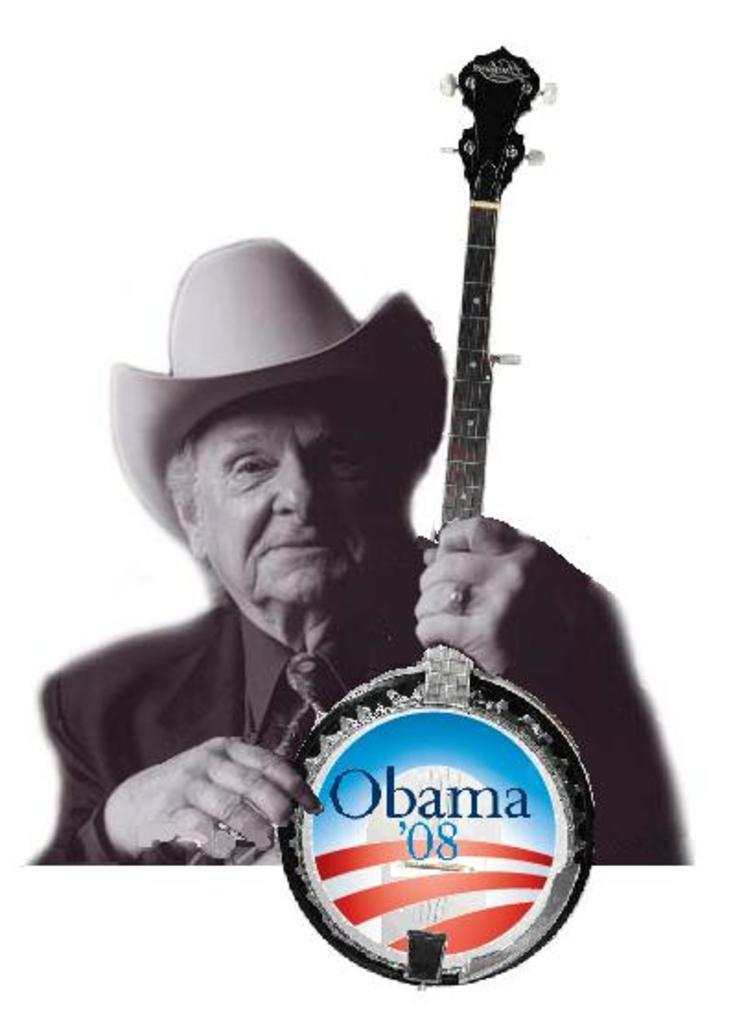Who is present in the image? A: There is a man in the image. What is the man holding in the image? The man is holding a musical instrument. What is depicted on the musical instrument? There is a picture of a building on the musical instrument. Are there any words or letters on the musical instrument? Yes, there is text on the musical instrument. What type of field is visible in the image? There is no field present in the image; it features a man holding a musical instrument with a picture of a building and text on it. 